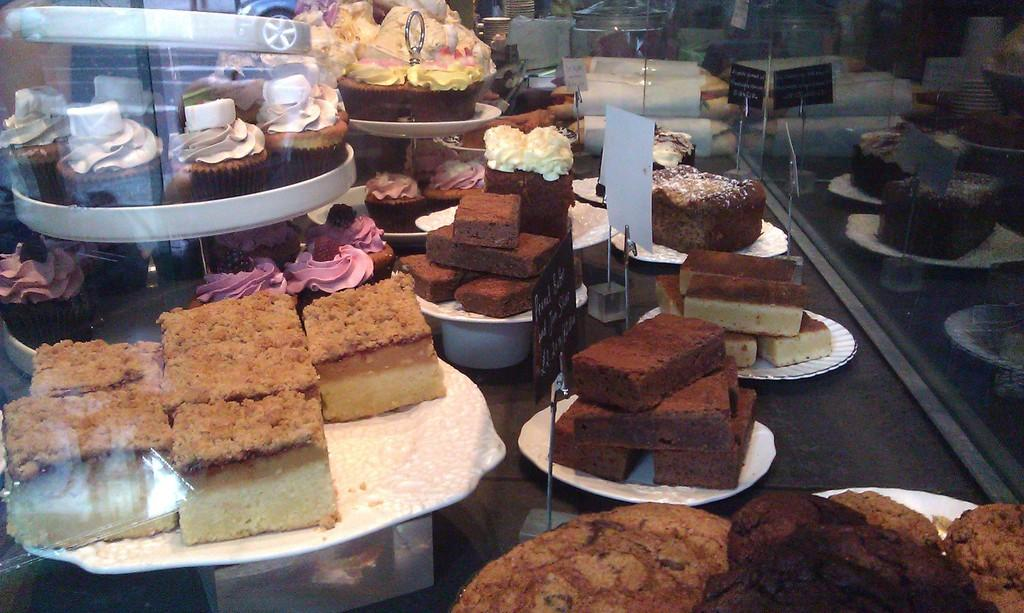What objects are present on the plates in the image? The plates contain sweets and cakes. Can you describe the contents of the plates in more detail? The plates contain sweets and cakes, which are both types of desserts. What type of pen is being used to write on the cakes in the image? There is no pen or writing on the cakes in the image; the plates only contain sweets and cakes. 